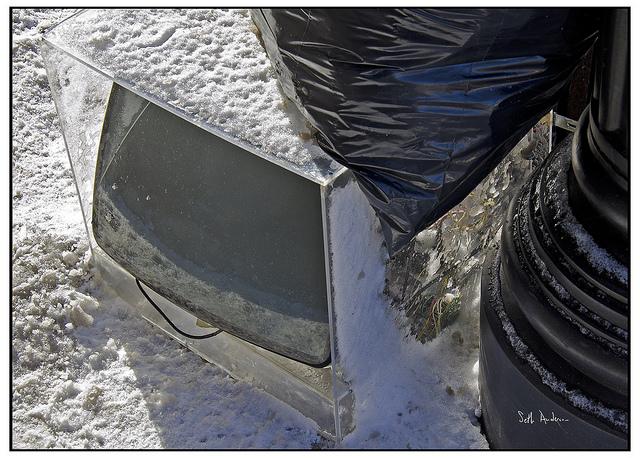Is there anything made of glass?
Concise answer only. Yes. What is in the black bag?
Be succinct. Trash. What is shown on the left?
Keep it brief. Tv. 